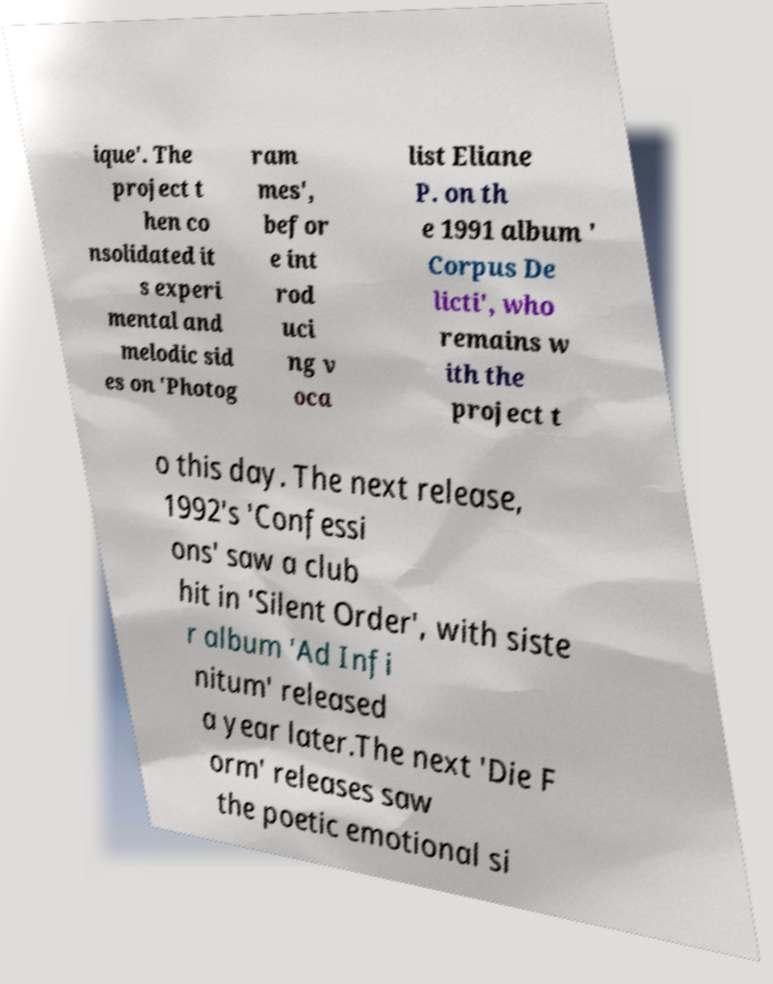Please identify and transcribe the text found in this image. ique'. The project t hen co nsolidated it s experi mental and melodic sid es on 'Photog ram mes', befor e int rod uci ng v oca list Eliane P. on th e 1991 album ' Corpus De licti', who remains w ith the project t o this day. The next release, 1992's 'Confessi ons' saw a club hit in 'Silent Order', with siste r album 'Ad Infi nitum' released a year later.The next 'Die F orm' releases saw the poetic emotional si 